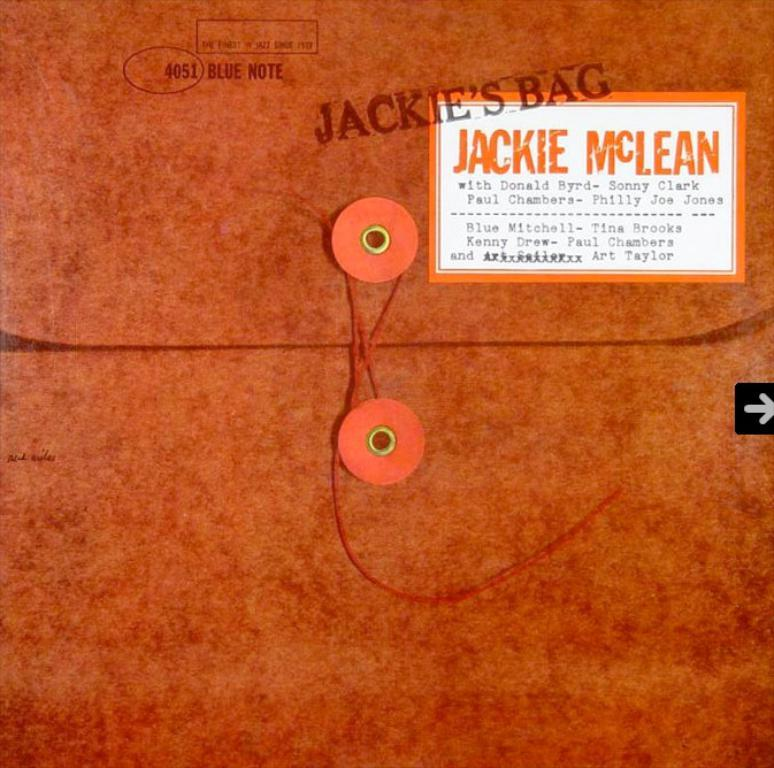What is the main subject of the image? The main subject of the image is a poster. What can be seen on the poster? The poster contains objects and threads. Is there any text present in the image? Yes, there is a label with text in the image. What else can be seen in the image besides the poster? There is a stamp visible in the image. How does the news affect the cart in the image? There is no news or cart present in the image; it only features a poster with objects, threads, a label with text, and a stamp. 